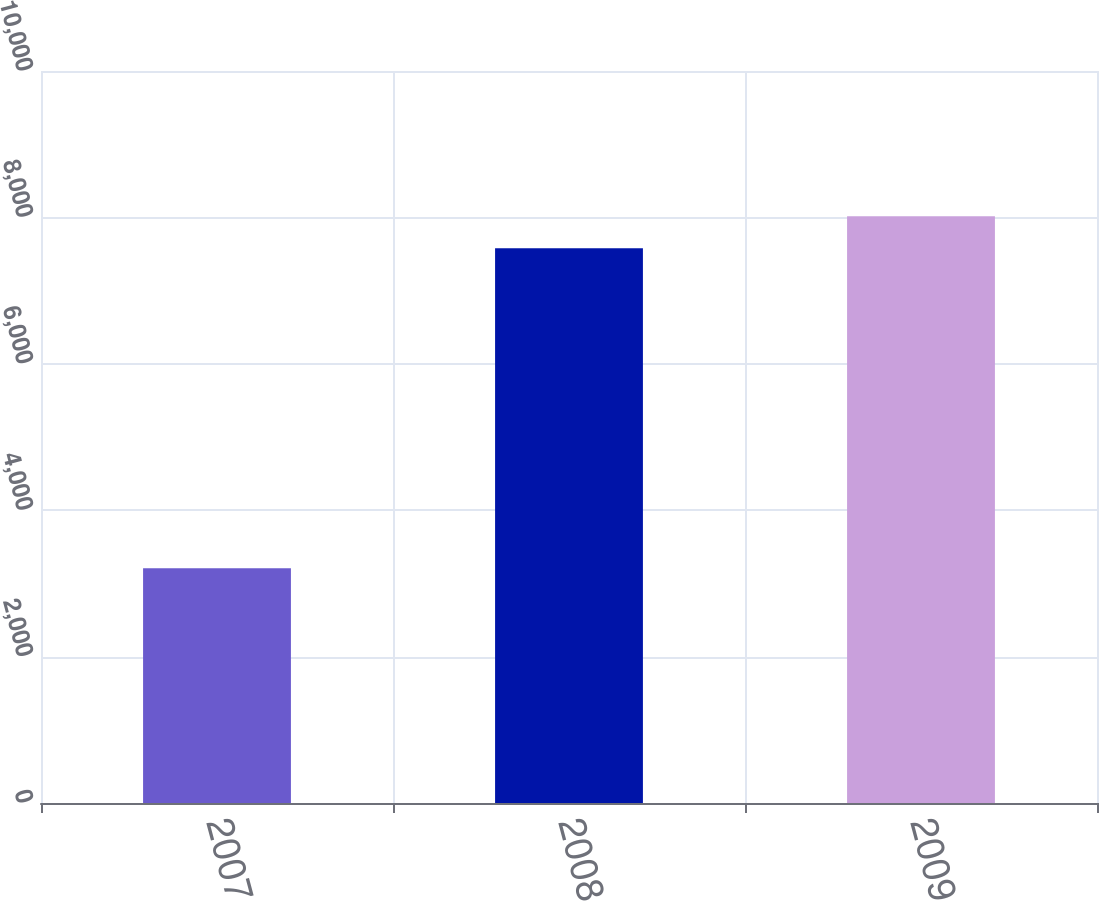Convert chart to OTSL. <chart><loc_0><loc_0><loc_500><loc_500><bar_chart><fcel>2007<fcel>2008<fcel>2009<nl><fcel>3206<fcel>7577<fcel>8014.1<nl></chart> 